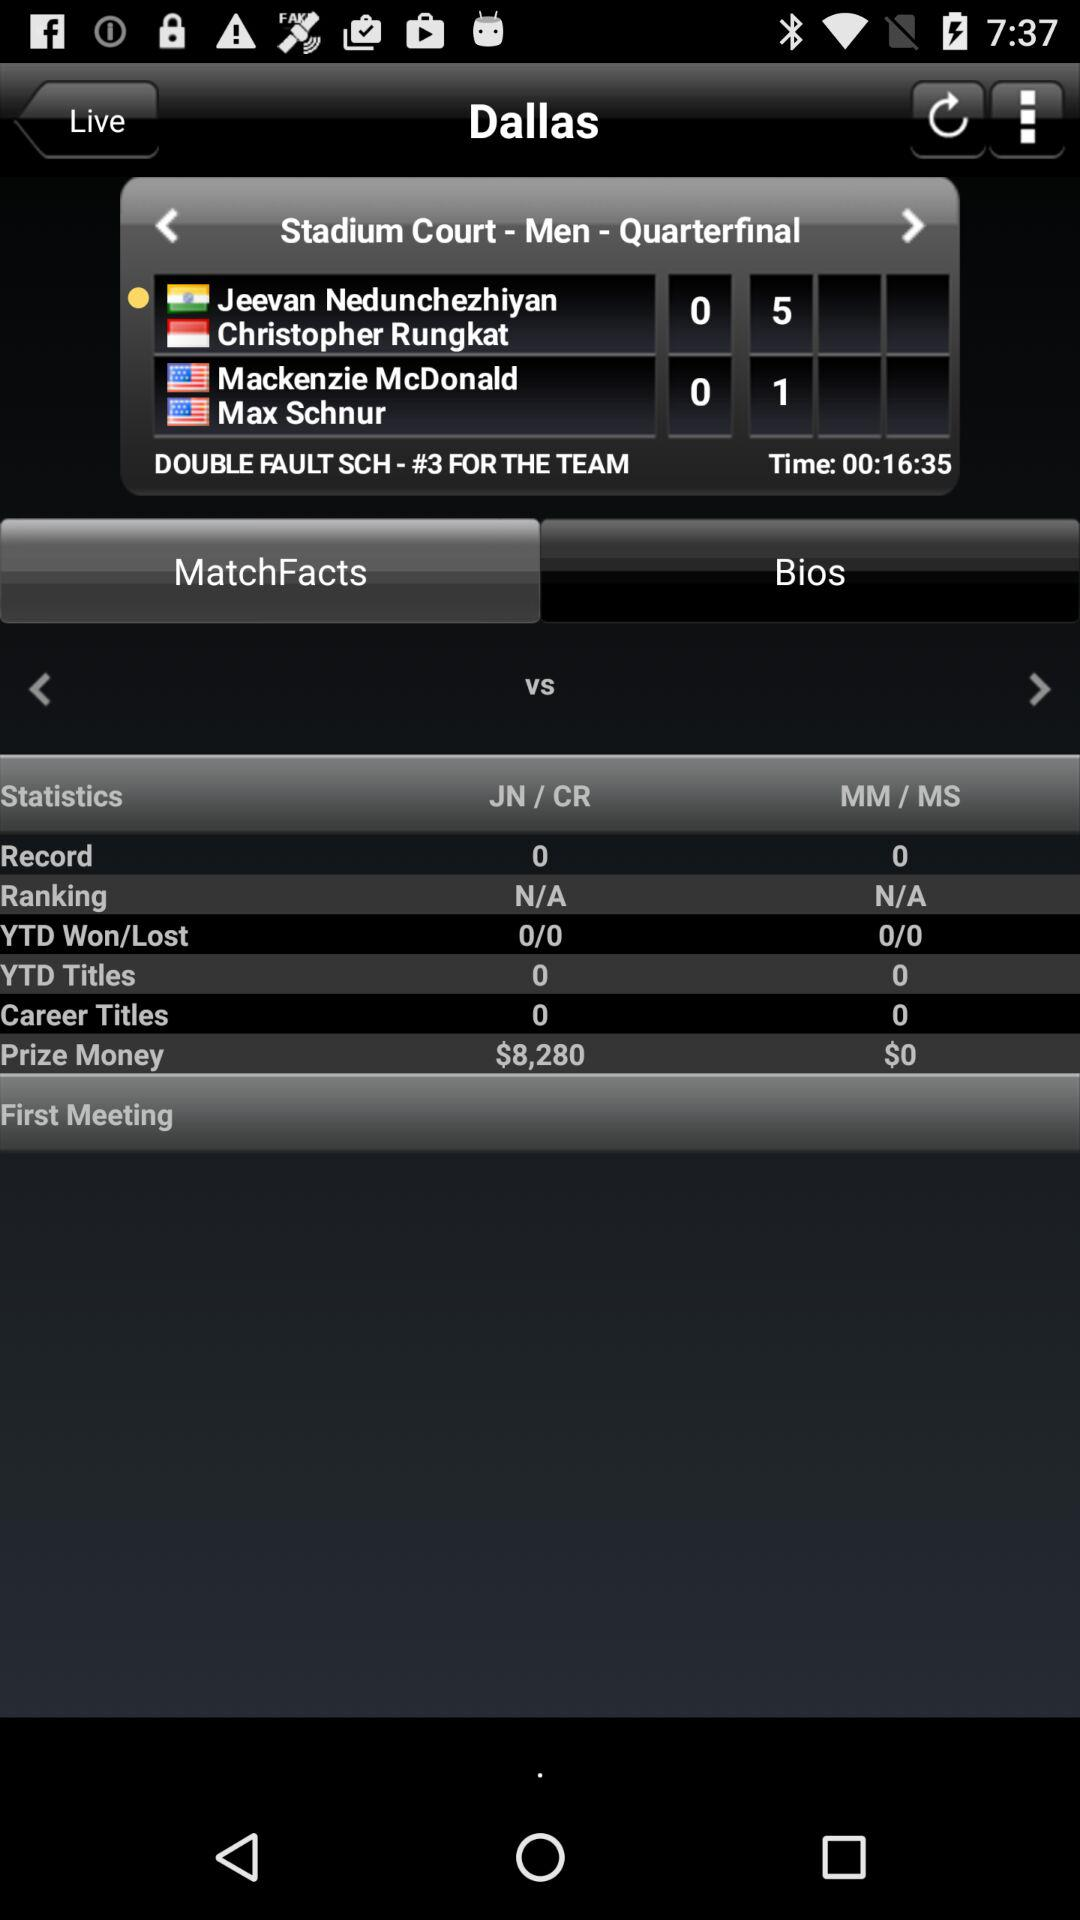What is the remaining time given on the screen? The remaining time is 16 minutes and 35 seconds. 